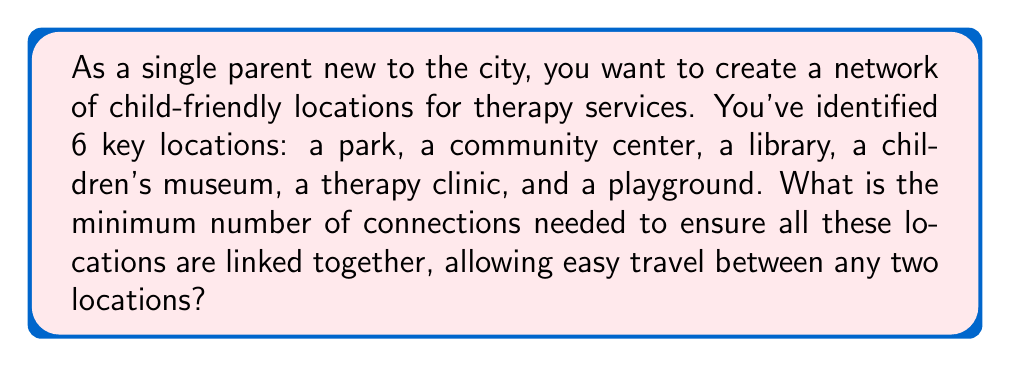What is the answer to this math problem? This problem can be solved using the concept of a minimum spanning tree in graph theory. Here's how we approach it:

1) First, we recognize that the locations represent vertices in a graph, and the connections between them are edges.

2) The question is asking for the minimum number of connections (edges) needed to link all locations (vertices). This is equivalent to finding a minimum spanning tree of the graph.

3) A key theorem in graph theory states that for any connected graph with $n$ vertices, a minimum spanning tree will have exactly $n-1$ edges.

4) In this case, we have 6 locations (vertices):
   $n = 6$

5) Therefore, the minimum number of connections (edges) needed is:
   $n - 1 = 6 - 1 = 5$

This solution ensures that all locations are connected with the minimum number of links, allowing travel between any two locations while minimizing the total number of connections that need to be established.

[asy]
unitsize(1cm);

pair[] points = {(0,0), (2,1), (1,2), (-1,2), (-2,1), (0,-2)};
string[] labels = {"Park", "Center", "Library", "Museum", "Clinic", "Playground"};

for(int i=0; i<6; ++i) {
  dot(points[i]);
  label(labels[i], points[i], E);
}

draw(points[0]--points[1]);
draw(points[1]--points[2]);
draw(points[2]--points[3]);
draw(points[3]--points[4]);
draw(points[4]--points[5]);
[/asy]

The diagram above shows one possible configuration of the minimum spanning tree connecting all 6 locations with 5 edges.
Answer: The minimum number of connections needed is 5. 